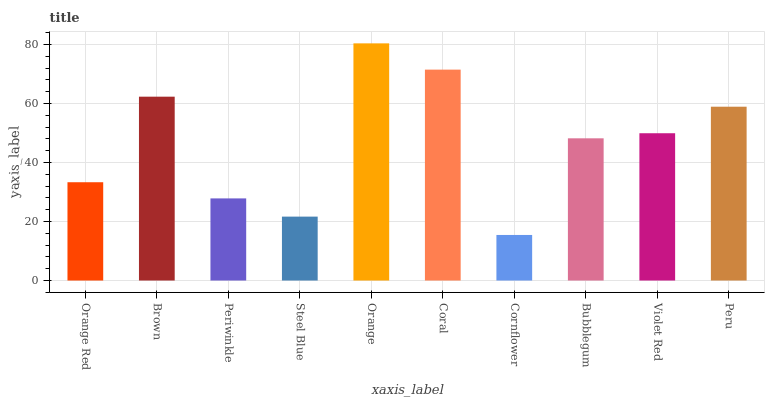Is Brown the minimum?
Answer yes or no. No. Is Brown the maximum?
Answer yes or no. No. Is Brown greater than Orange Red?
Answer yes or no. Yes. Is Orange Red less than Brown?
Answer yes or no. Yes. Is Orange Red greater than Brown?
Answer yes or no. No. Is Brown less than Orange Red?
Answer yes or no. No. Is Violet Red the high median?
Answer yes or no. Yes. Is Bubblegum the low median?
Answer yes or no. Yes. Is Coral the high median?
Answer yes or no. No. Is Coral the low median?
Answer yes or no. No. 